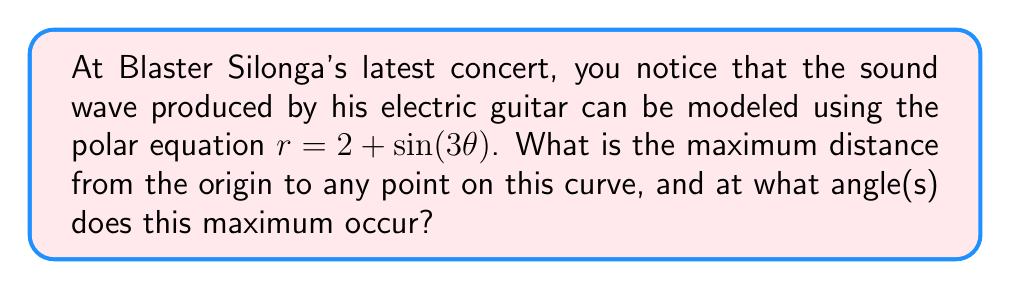Help me with this question. To solve this problem, we need to follow these steps:

1) The equation $r = 2 + \sin(3\theta)$ represents a polar curve. The maximum distance from the origin will occur when $r$ is at its maximum value.

2) We know that the sine function has a maximum value of 1 and a minimum value of -1. Therefore, the maximum value of $r$ will occur when $\sin(3\theta) = 1$.

3) To find the maximum $r$ value:
   $$r_{max} = 2 + 1 = 3$$

4) To find the angle(s) at which this maximum occurs, we need to solve:
   $$\sin(3\theta) = 1$$

5) The general solution for this equation is:
   $$3\theta = \frac{\pi}{2} + 2\pi n, \text{ where } n \text{ is an integer}$$

6) Solving for $\theta$:
   $$\theta = \frac{\pi}{6} + \frac{2\pi n}{3}, \text{ where } n \text{ is an integer}$$

7) The first solution (when $n = 0$) is $\theta = \frac{\pi}{6}$ or 30°. 
   The next solutions within the range $[0, 2\pi]$ are:
   - When $n = 1$: $\theta = \frac{5\pi}{6}$ or 150°
   - When $n = 2$: $\theta = \frac{3\pi}{2}$ or 270°

Therefore, the maximum distance from the origin is 3 units, and this occurs at angles 30°, 150°, and 270°.
Answer: The maximum distance from the origin is 3 units, occurring at angles $\theta = \frac{\pi}{6}$, $\frac{5\pi}{6}$, and $\frac{3\pi}{2}$ radians (or 30°, 150°, and 270°). 